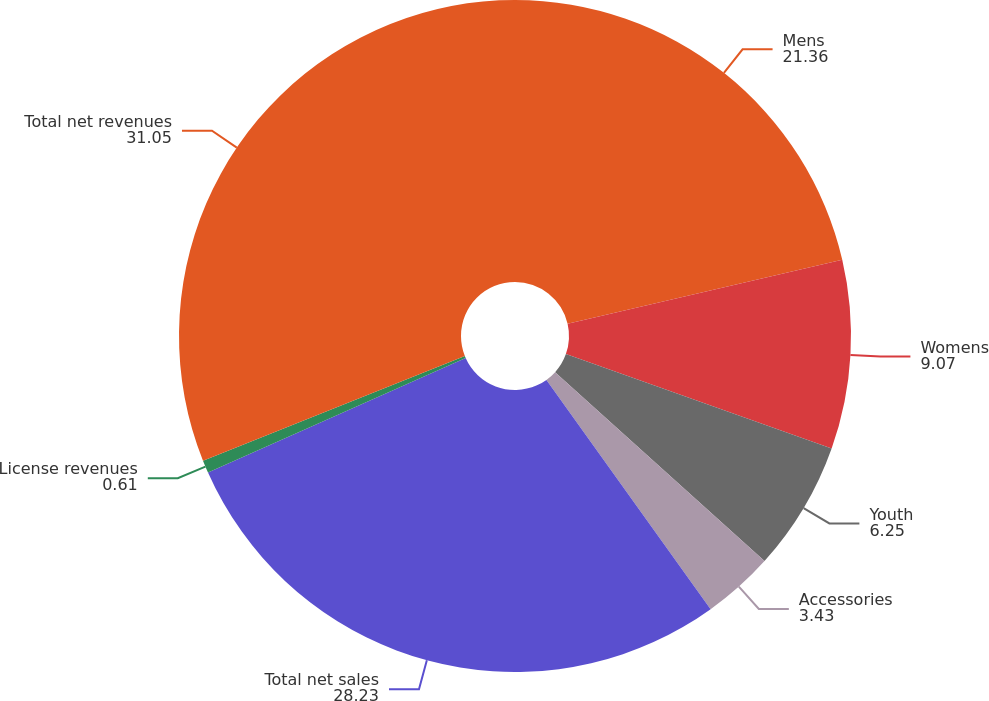<chart> <loc_0><loc_0><loc_500><loc_500><pie_chart><fcel>Mens<fcel>Womens<fcel>Youth<fcel>Accessories<fcel>Total net sales<fcel>License revenues<fcel>Total net revenues<nl><fcel>21.36%<fcel>9.07%<fcel>6.25%<fcel>3.43%<fcel>28.23%<fcel>0.61%<fcel>31.05%<nl></chart> 